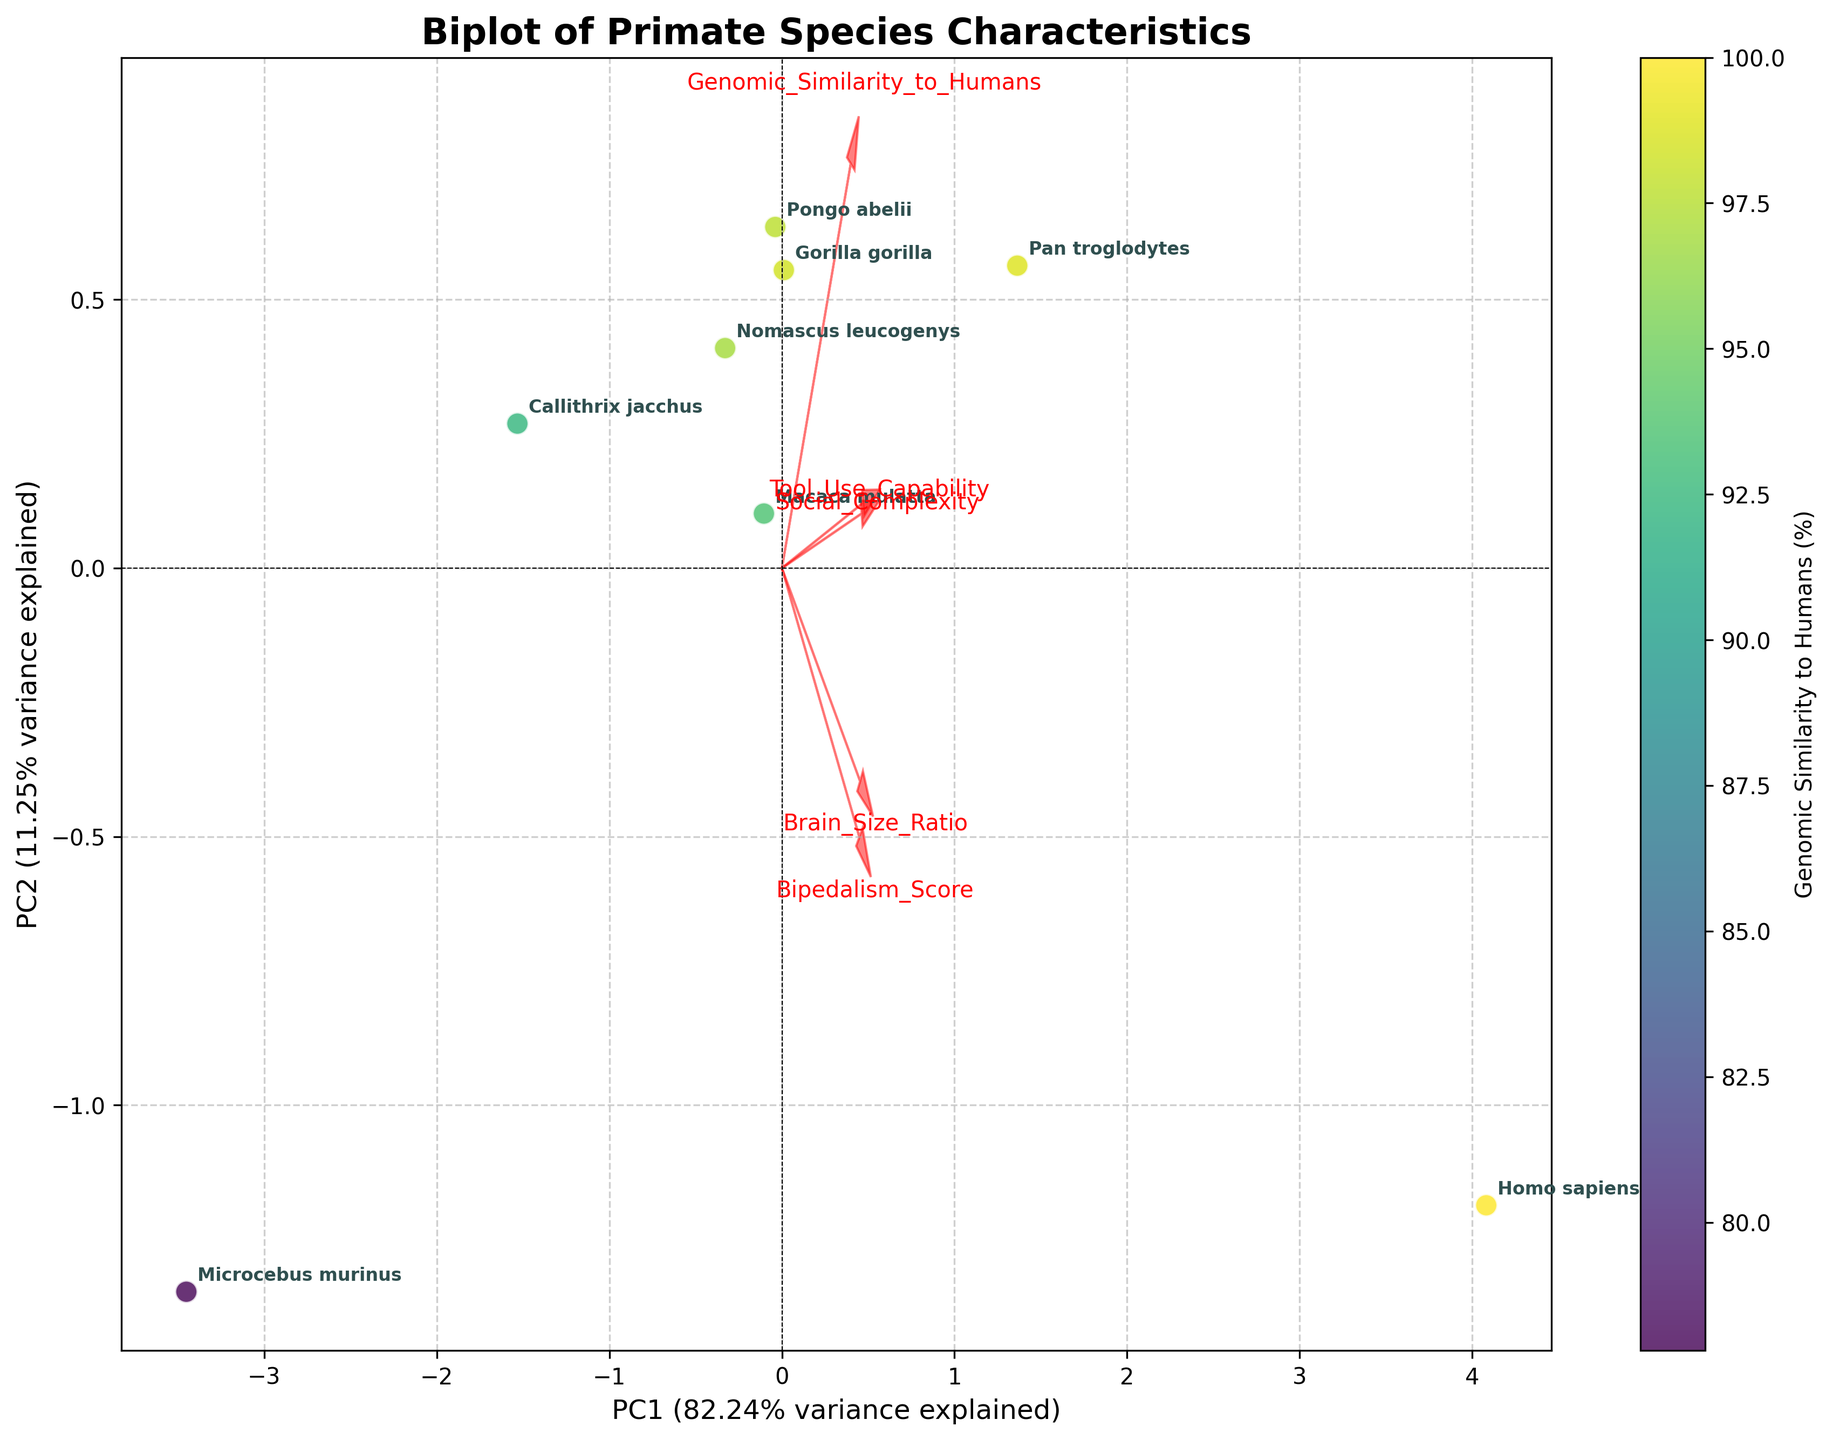What is the title of the biplot? The title of the plot is prominently displayed at the top of the figure. By reading the text directly from the plot, we can determine the title.
Answer: Biplot of Primate Species Characteristics How many data points are represented in the figure? Each species in the dataset is represented as a data point in the plot. By counting the number of distinct species annotations, we can determine the total number of data points. In this case, there are eight species listed.
Answer: 8 Which axis represents the variance explained by PC1, and what is the percentage of variance explained? The x-axis of the biplot represents PC1. The label on the x-axis includes both the identifier "PC1" and the percentage of variance it explains.
Answer: x-axis, 63.01% Which species is closest to humans in terms of genomic similarity according to the plot? By observing the color gradient on the plot, which represents genomic similarity to humans, Homo sapiens would be the data point with the highest genomic similarity. By comparing the annotated species, we can see that Homo sapiens are denoted in a specific point with maximal coloration.
Answer: Pan troglodytes Identify the feature vector with the largest horizontal component. What is its name? Feature vectors are represented as arrows on a biplot. The horizontal component can be evaluated by looking at the extent of each arrow along the x-axis (PC1). The feature with the largest horizontal projection is the one that extends the farthest right or left.
Answer: Genomic_Similarity_to_Humans Which species exhibits the lowest value of Brain Size Ratio in the biplot? By locating the annotations for Callithrix jacchus within the biplot, we can identify that it is the species represented by a data point near the lower end of the Brain Size Ratio. This is corroborated by observing the specific Brain Size Ratio values in the dataset.
Answer: Callithrix jacchus Which features have a positive correlation with PC1? Features that have a positive correlation with PC1 will have arrows pointing rightward in the biplot. By examining the direction of all the labeled feature vectors, we can see which ones are oriented towards the right side (x-axis).
Answer: Genomic_Similarity_to_Humans, Brain_Size_Ratio, Tool_Use_Capability, Social_Complexity Which two species are most similar based on their positions in the biplot space? The relative positions of species on the biplot can reveal their overall similarity based on the plotted principal components. Closely located points indicate that those species are similar in the dimensions considered.
Answer: Pan troglodytes and Gorilla gorilla Does Bipedalism_Score have a stronger influence on PC1 or PC2? To determine the influence of Bipedalism_Score on PC1 and PC2, examine the direction and length of the corresponding arrow. The component with the more extended projection signifies a stronger influence.
Answer: PC2 